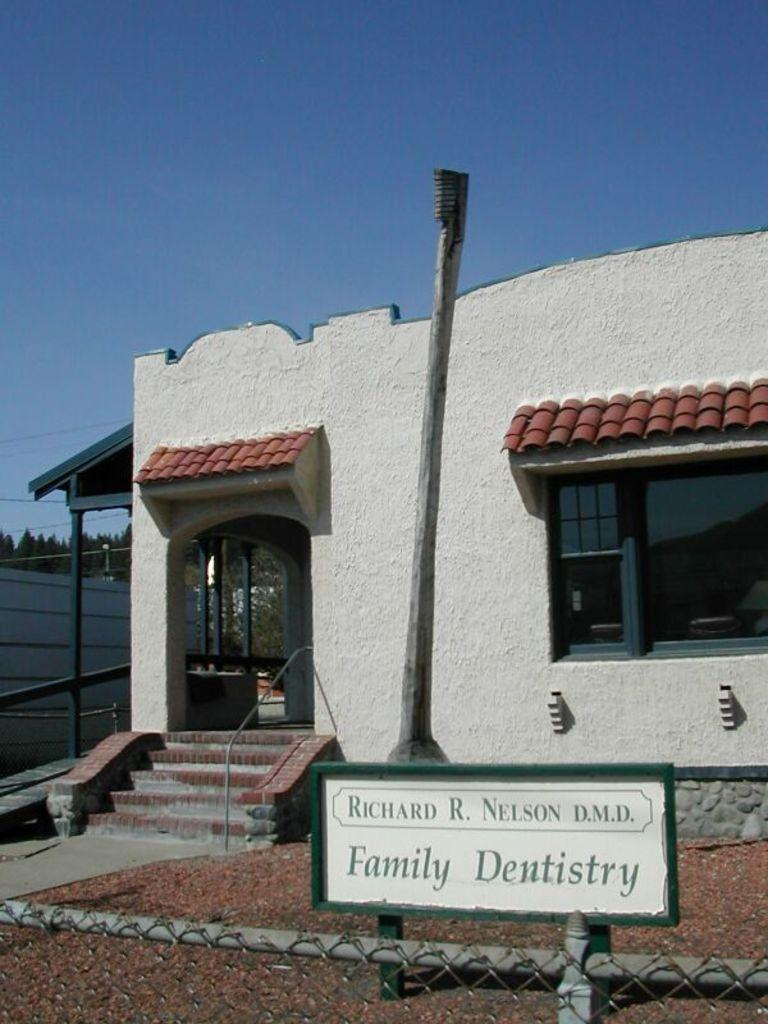What type of structure is visible in the image? There is a house in the image. What part of the house can be seen in the image? There is a window in the image. What other objects are present in the image? There is a pole, a board, and a fence in the image. What can be seen in the background of the image? There are trees, a wall, and the sky visible in the background of the image. What type of berry is growing on the frame in the image? There is no berry or frame present in the image. 